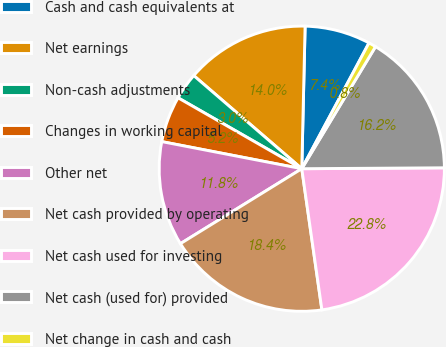<chart> <loc_0><loc_0><loc_500><loc_500><pie_chart><fcel>Cash and cash equivalents at<fcel>Net earnings<fcel>Non-cash adjustments<fcel>Changes in working capital<fcel>Other net<fcel>Net cash provided by operating<fcel>Net cash used for investing<fcel>Net cash (used for) provided<fcel>Net change in cash and cash<nl><fcel>7.44%<fcel>14.05%<fcel>3.04%<fcel>5.24%<fcel>11.85%<fcel>18.45%<fcel>22.85%<fcel>16.25%<fcel>0.84%<nl></chart> 